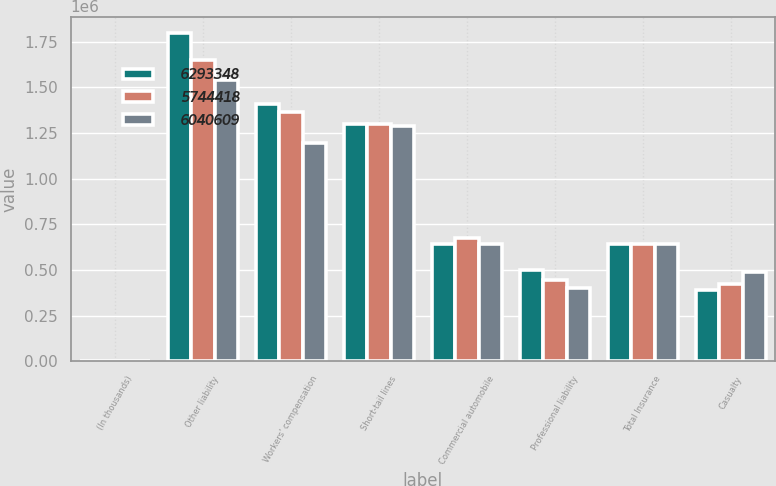Convert chart. <chart><loc_0><loc_0><loc_500><loc_500><stacked_bar_chart><ecel><fcel>(In thousands)<fcel>Other liability<fcel>Workers' compensation<fcel>Short-tail lines<fcel>Commercial automobile<fcel>Professional liability<fcel>Total Insurance<fcel>Casualty<nl><fcel>6.29335e+06<fcel>2016<fcel>1.79877e+06<fcel>1.40891e+06<fcel>1.29954e+06<fcel>642452<fcel>503224<fcel>642713<fcel>390863<nl><fcel>5.74442e+06<fcel>2015<fcel>1.65013e+06<fcel>1.36351e+06<fcel>1.29888e+06<fcel>674078<fcel>444895<fcel>642713<fcel>421811<nl><fcel>6.04061e+06<fcel>2014<fcel>1.54184e+06<fcel>1.1987e+06<fcel>1.29102e+06<fcel>642713<fcel>400037<fcel>642713<fcel>487264<nl></chart> 